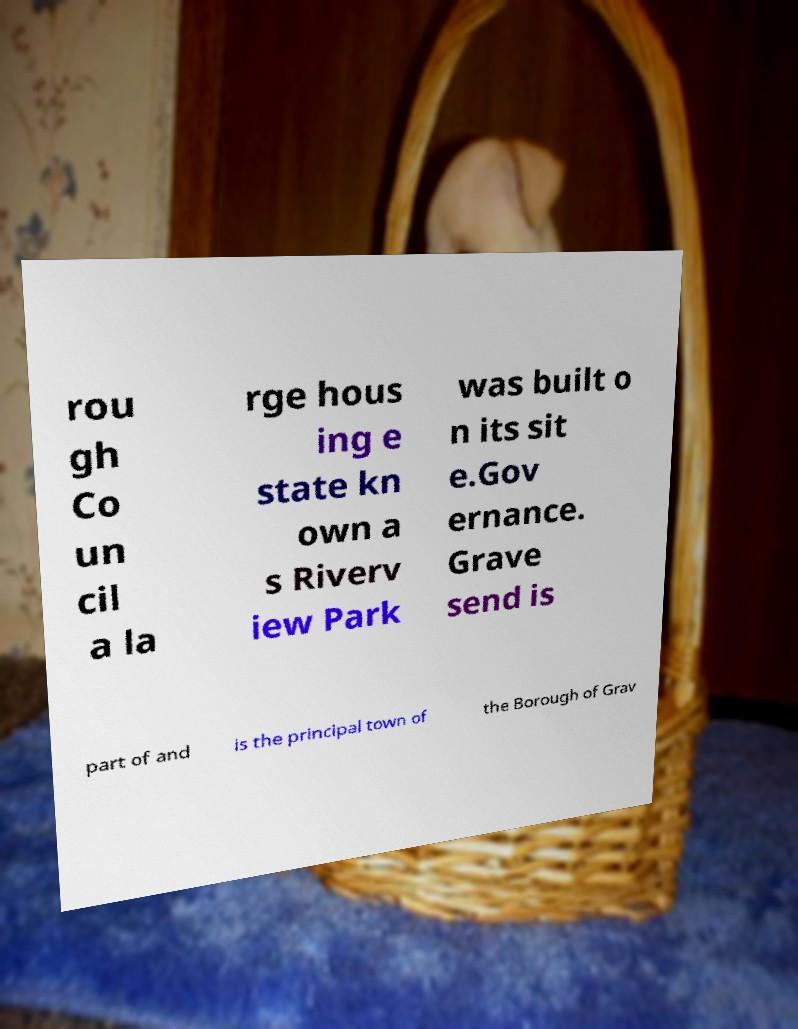Please read and relay the text visible in this image. What does it say? rou gh Co un cil a la rge hous ing e state kn own a s Riverv iew Park was built o n its sit e.Gov ernance. Grave send is part of and is the principal town of the Borough of Grav 